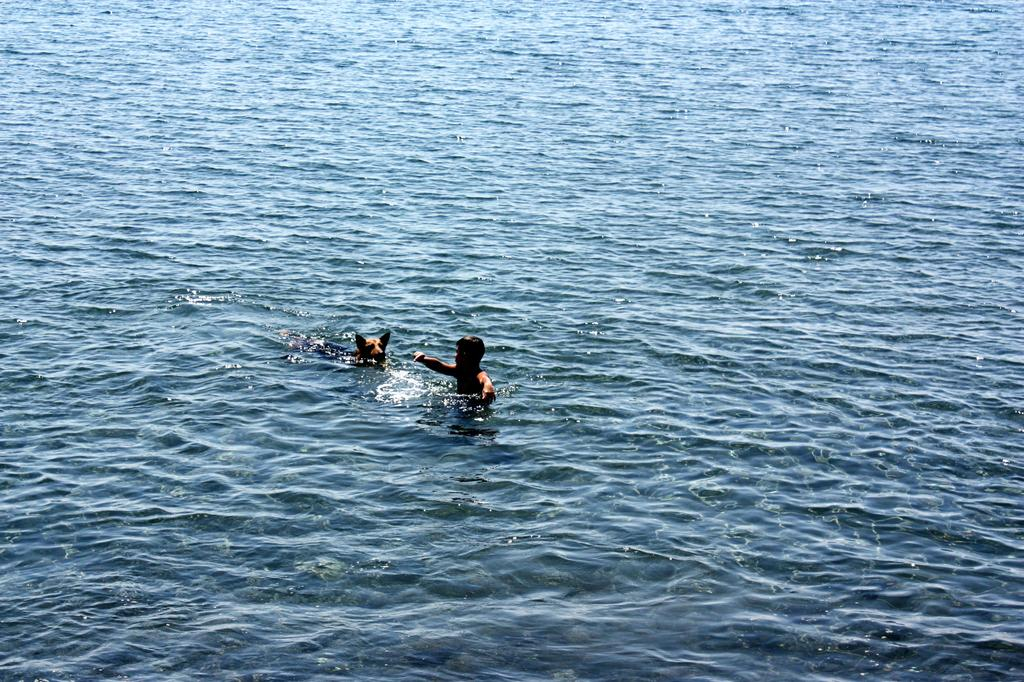What is present in the image? There is water in the image. Who or what is in the water? There is a man and a dog in the water. What type of kettle can be seen in the image? There is no kettle present in the image. How many bears are visible in the water? There are no bears visible in the water; only a man and a dog are present. 